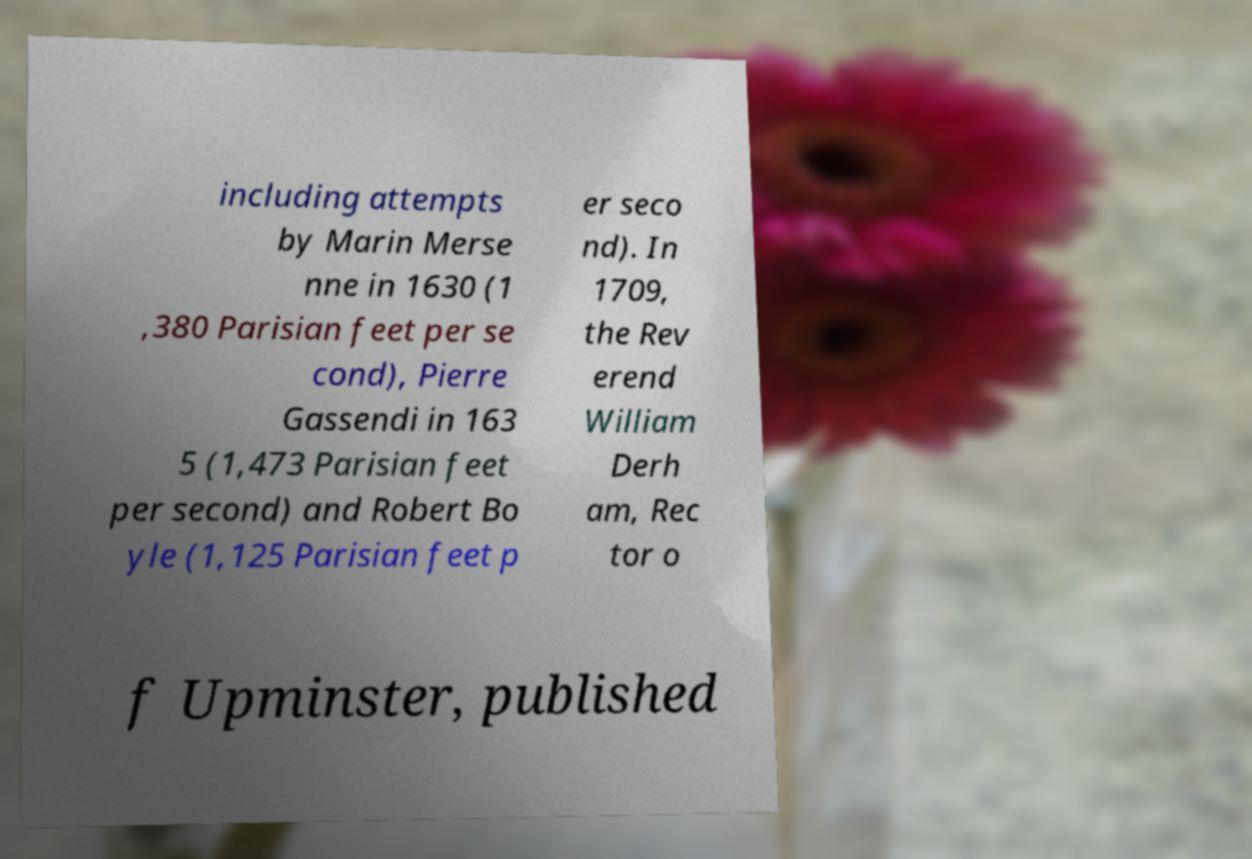I need the written content from this picture converted into text. Can you do that? including attempts by Marin Merse nne in 1630 (1 ,380 Parisian feet per se cond), Pierre Gassendi in 163 5 (1,473 Parisian feet per second) and Robert Bo yle (1,125 Parisian feet p er seco nd). In 1709, the Rev erend William Derh am, Rec tor o f Upminster, published 